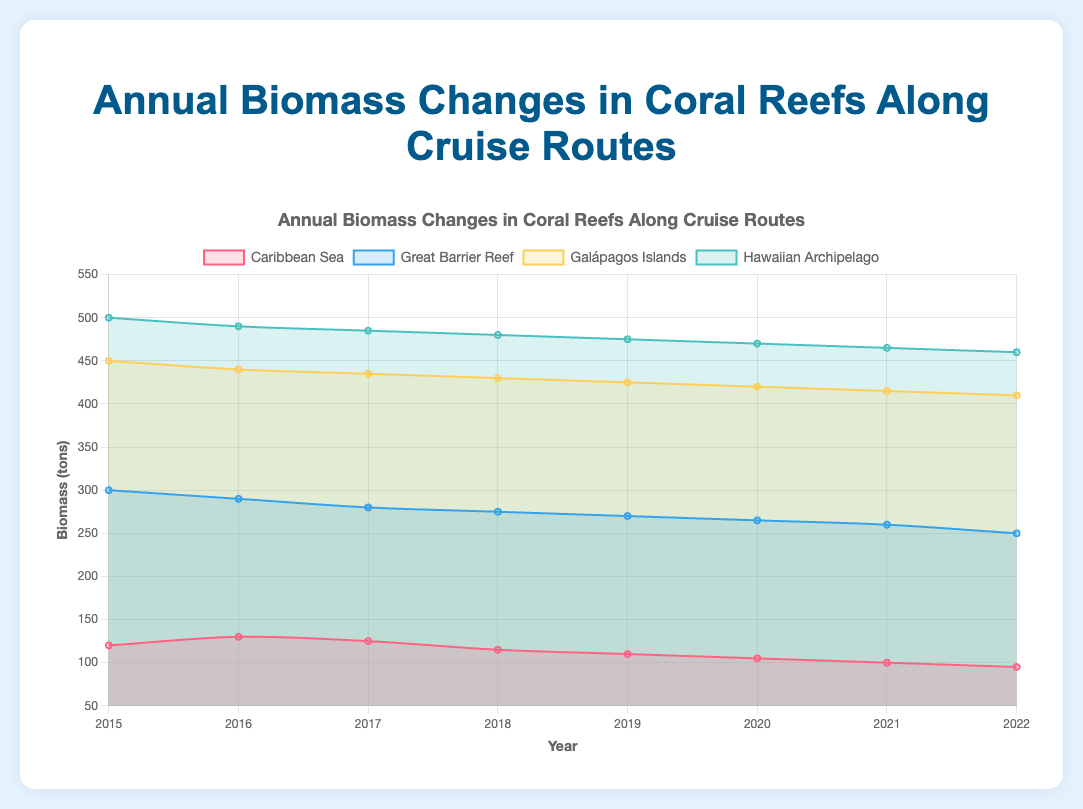what is the title of the figure? The title of the figure is prominently displayed at the top center, stating what the graph represents.
Answer: Annual Biomass Changes in Coral Reefs Along Cruise Routes Which location had the highest biomass in 2017? By examining the data points for 2017, the Hawaiian Archipelago consistently shows the highest biomass levels across all years.
Answer: Hawaiian Archipelago How did the biomass in the Caribbean Sea change from 2015 to 2022? The biomass data points for the Caribbean Sea from 2015 to 2022 show a decreasing trend, dropping from 120 tons in 2015 to 95 tons in 2022.
Answer: Decreased What is the average biomass in the Great Barrier Reef over the years shown? To find the average biomass, add the biomass values for each year from the Great Barrier Reef and divide by the number of years. Sum = 300 + 290 + 280 + 275 + 270 + 265 + 260 + 250 = 2190. The number of years is 8, so the average is 2190/8 = 273.75.
Answer: 273.75 tons Which route experienced the steepest decline in biomass from 2015 to 2022? By visually comparing the slopes of the lines representing each route, the Great Barrier Reef shows the steepest decline in biomass from 300 tons in 2015 to 250 tons in 2022.
Answer: Great Barrier Reef Between which years did the Galápagos Islands experience the smallest change in biomass? The Galápagos Islands’ biomass changes minimally between consecutive years, with the smallest change of 5 tons observed between several year pairs, such as 2021 to 2022, where it declined from 415 to 410.
Answer: 2021 to 2022 How many routes are shown in the chart? The chart presents separate datasets for distinct routes, color-coded and labeled for clarity; counting these provides the answer.
Answer: Four routes Which year had the highest overall biomass across all locations combined? Sum the biomass values for all routes for each year and identify the year with the highest total. For example, 2015: 120 + 300 + 450 + 500 = 1370; 2016: 130 + 290 + 440 + 490 = 1350. 1370 being the highest.
Answer: 2015 What trend can be observed in the biomass changes within the Hawaiian Archipelago over these years? Observing the line representing the Hawaiian Archipelago, a consistent downward trend in biomass is evident from 500 tons in 2015 to 460 tons in 2022.
Answer: Decreasing trend Compare the biomass of the Caribbean Sea and Great Barrier Reef in 2020. Check the values represented for both routes in 2020; the Caribbean Sea shows 105 tons and the Great Barrier Reef shows 265 tons.
Answer: The Great Barrier Reef had higher biomass than the Caribbean Sea 